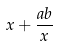Convert formula to latex. <formula><loc_0><loc_0><loc_500><loc_500>x + \frac { a b } { x }</formula> 